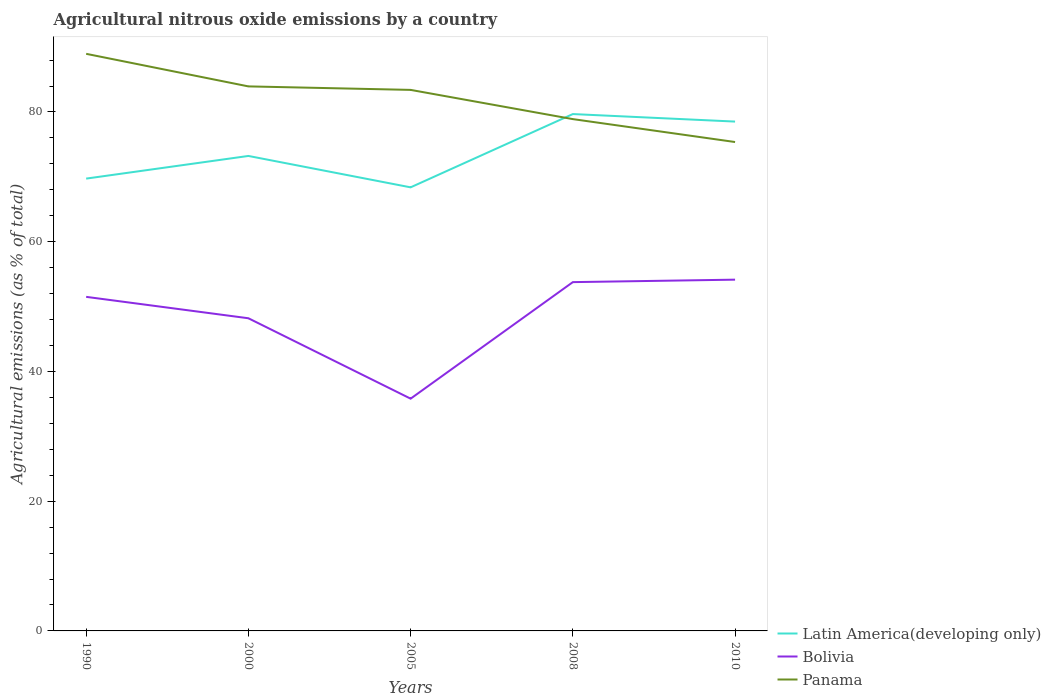Does the line corresponding to Bolivia intersect with the line corresponding to Panama?
Your answer should be compact. No. Is the number of lines equal to the number of legend labels?
Provide a short and direct response. Yes. Across all years, what is the maximum amount of agricultural nitrous oxide emitted in Panama?
Offer a very short reply. 75.37. What is the total amount of agricultural nitrous oxide emitted in Panama in the graph?
Provide a short and direct response. 4.5. What is the difference between the highest and the second highest amount of agricultural nitrous oxide emitted in Panama?
Your answer should be compact. 13.6. What is the difference between the highest and the lowest amount of agricultural nitrous oxide emitted in Bolivia?
Give a very brief answer. 3. Is the amount of agricultural nitrous oxide emitted in Panama strictly greater than the amount of agricultural nitrous oxide emitted in Latin America(developing only) over the years?
Ensure brevity in your answer.  No. What is the difference between two consecutive major ticks on the Y-axis?
Offer a terse response. 20. Are the values on the major ticks of Y-axis written in scientific E-notation?
Offer a very short reply. No. How are the legend labels stacked?
Provide a succinct answer. Vertical. What is the title of the graph?
Ensure brevity in your answer.  Agricultural nitrous oxide emissions by a country. What is the label or title of the Y-axis?
Give a very brief answer. Agricultural emissions (as % of total). What is the Agricultural emissions (as % of total) of Latin America(developing only) in 1990?
Provide a succinct answer. 69.73. What is the Agricultural emissions (as % of total) of Bolivia in 1990?
Provide a succinct answer. 51.5. What is the Agricultural emissions (as % of total) in Panama in 1990?
Your response must be concise. 88.97. What is the Agricultural emissions (as % of total) in Latin America(developing only) in 2000?
Offer a very short reply. 73.22. What is the Agricultural emissions (as % of total) in Bolivia in 2000?
Ensure brevity in your answer.  48.2. What is the Agricultural emissions (as % of total) of Panama in 2000?
Ensure brevity in your answer.  83.94. What is the Agricultural emissions (as % of total) in Latin America(developing only) in 2005?
Make the answer very short. 68.38. What is the Agricultural emissions (as % of total) of Bolivia in 2005?
Offer a terse response. 35.8. What is the Agricultural emissions (as % of total) in Panama in 2005?
Ensure brevity in your answer.  83.41. What is the Agricultural emissions (as % of total) of Latin America(developing only) in 2008?
Give a very brief answer. 79.68. What is the Agricultural emissions (as % of total) in Bolivia in 2008?
Your answer should be compact. 53.77. What is the Agricultural emissions (as % of total) in Panama in 2008?
Provide a succinct answer. 78.9. What is the Agricultural emissions (as % of total) of Latin America(developing only) in 2010?
Give a very brief answer. 78.52. What is the Agricultural emissions (as % of total) in Bolivia in 2010?
Offer a terse response. 54.15. What is the Agricultural emissions (as % of total) in Panama in 2010?
Your answer should be very brief. 75.37. Across all years, what is the maximum Agricultural emissions (as % of total) of Latin America(developing only)?
Provide a short and direct response. 79.68. Across all years, what is the maximum Agricultural emissions (as % of total) of Bolivia?
Your answer should be very brief. 54.15. Across all years, what is the maximum Agricultural emissions (as % of total) of Panama?
Give a very brief answer. 88.97. Across all years, what is the minimum Agricultural emissions (as % of total) of Latin America(developing only)?
Make the answer very short. 68.38. Across all years, what is the minimum Agricultural emissions (as % of total) in Bolivia?
Give a very brief answer. 35.8. Across all years, what is the minimum Agricultural emissions (as % of total) in Panama?
Your answer should be very brief. 75.37. What is the total Agricultural emissions (as % of total) in Latin America(developing only) in the graph?
Give a very brief answer. 369.54. What is the total Agricultural emissions (as % of total) of Bolivia in the graph?
Make the answer very short. 243.43. What is the total Agricultural emissions (as % of total) of Panama in the graph?
Your answer should be compact. 410.59. What is the difference between the Agricultural emissions (as % of total) in Latin America(developing only) in 1990 and that in 2000?
Provide a succinct answer. -3.49. What is the difference between the Agricultural emissions (as % of total) of Bolivia in 1990 and that in 2000?
Offer a terse response. 3.3. What is the difference between the Agricultural emissions (as % of total) in Panama in 1990 and that in 2000?
Give a very brief answer. 5.02. What is the difference between the Agricultural emissions (as % of total) in Latin America(developing only) in 1990 and that in 2005?
Offer a terse response. 1.35. What is the difference between the Agricultural emissions (as % of total) in Bolivia in 1990 and that in 2005?
Provide a short and direct response. 15.7. What is the difference between the Agricultural emissions (as % of total) in Panama in 1990 and that in 2005?
Your answer should be compact. 5.56. What is the difference between the Agricultural emissions (as % of total) in Latin America(developing only) in 1990 and that in 2008?
Your answer should be very brief. -9.95. What is the difference between the Agricultural emissions (as % of total) of Bolivia in 1990 and that in 2008?
Ensure brevity in your answer.  -2.27. What is the difference between the Agricultural emissions (as % of total) of Panama in 1990 and that in 2008?
Make the answer very short. 10.07. What is the difference between the Agricultural emissions (as % of total) of Latin America(developing only) in 1990 and that in 2010?
Provide a short and direct response. -8.79. What is the difference between the Agricultural emissions (as % of total) of Bolivia in 1990 and that in 2010?
Make the answer very short. -2.65. What is the difference between the Agricultural emissions (as % of total) in Panama in 1990 and that in 2010?
Make the answer very short. 13.6. What is the difference between the Agricultural emissions (as % of total) of Latin America(developing only) in 2000 and that in 2005?
Ensure brevity in your answer.  4.84. What is the difference between the Agricultural emissions (as % of total) in Bolivia in 2000 and that in 2005?
Your answer should be very brief. 12.4. What is the difference between the Agricultural emissions (as % of total) of Panama in 2000 and that in 2005?
Give a very brief answer. 0.54. What is the difference between the Agricultural emissions (as % of total) of Latin America(developing only) in 2000 and that in 2008?
Your answer should be very brief. -6.46. What is the difference between the Agricultural emissions (as % of total) of Bolivia in 2000 and that in 2008?
Make the answer very short. -5.57. What is the difference between the Agricultural emissions (as % of total) in Panama in 2000 and that in 2008?
Give a very brief answer. 5.04. What is the difference between the Agricultural emissions (as % of total) of Latin America(developing only) in 2000 and that in 2010?
Your answer should be very brief. -5.3. What is the difference between the Agricultural emissions (as % of total) in Bolivia in 2000 and that in 2010?
Offer a terse response. -5.95. What is the difference between the Agricultural emissions (as % of total) of Panama in 2000 and that in 2010?
Your answer should be very brief. 8.58. What is the difference between the Agricultural emissions (as % of total) in Latin America(developing only) in 2005 and that in 2008?
Offer a terse response. -11.3. What is the difference between the Agricultural emissions (as % of total) of Bolivia in 2005 and that in 2008?
Your answer should be compact. -17.97. What is the difference between the Agricultural emissions (as % of total) of Panama in 2005 and that in 2008?
Provide a short and direct response. 4.5. What is the difference between the Agricultural emissions (as % of total) in Latin America(developing only) in 2005 and that in 2010?
Offer a very short reply. -10.14. What is the difference between the Agricultural emissions (as % of total) of Bolivia in 2005 and that in 2010?
Keep it short and to the point. -18.35. What is the difference between the Agricultural emissions (as % of total) of Panama in 2005 and that in 2010?
Offer a terse response. 8.04. What is the difference between the Agricultural emissions (as % of total) of Latin America(developing only) in 2008 and that in 2010?
Offer a terse response. 1.16. What is the difference between the Agricultural emissions (as % of total) in Bolivia in 2008 and that in 2010?
Your answer should be compact. -0.38. What is the difference between the Agricultural emissions (as % of total) in Panama in 2008 and that in 2010?
Your response must be concise. 3.53. What is the difference between the Agricultural emissions (as % of total) in Latin America(developing only) in 1990 and the Agricultural emissions (as % of total) in Bolivia in 2000?
Make the answer very short. 21.53. What is the difference between the Agricultural emissions (as % of total) in Latin America(developing only) in 1990 and the Agricultural emissions (as % of total) in Panama in 2000?
Keep it short and to the point. -14.22. What is the difference between the Agricultural emissions (as % of total) in Bolivia in 1990 and the Agricultural emissions (as % of total) in Panama in 2000?
Provide a short and direct response. -32.44. What is the difference between the Agricultural emissions (as % of total) of Latin America(developing only) in 1990 and the Agricultural emissions (as % of total) of Bolivia in 2005?
Provide a short and direct response. 33.92. What is the difference between the Agricultural emissions (as % of total) in Latin America(developing only) in 1990 and the Agricultural emissions (as % of total) in Panama in 2005?
Make the answer very short. -13.68. What is the difference between the Agricultural emissions (as % of total) of Bolivia in 1990 and the Agricultural emissions (as % of total) of Panama in 2005?
Provide a short and direct response. -31.91. What is the difference between the Agricultural emissions (as % of total) of Latin America(developing only) in 1990 and the Agricultural emissions (as % of total) of Bolivia in 2008?
Offer a very short reply. 15.96. What is the difference between the Agricultural emissions (as % of total) in Latin America(developing only) in 1990 and the Agricultural emissions (as % of total) in Panama in 2008?
Offer a very short reply. -9.17. What is the difference between the Agricultural emissions (as % of total) in Bolivia in 1990 and the Agricultural emissions (as % of total) in Panama in 2008?
Ensure brevity in your answer.  -27.4. What is the difference between the Agricultural emissions (as % of total) of Latin America(developing only) in 1990 and the Agricultural emissions (as % of total) of Bolivia in 2010?
Ensure brevity in your answer.  15.58. What is the difference between the Agricultural emissions (as % of total) of Latin America(developing only) in 1990 and the Agricultural emissions (as % of total) of Panama in 2010?
Keep it short and to the point. -5.64. What is the difference between the Agricultural emissions (as % of total) of Bolivia in 1990 and the Agricultural emissions (as % of total) of Panama in 2010?
Your answer should be compact. -23.87. What is the difference between the Agricultural emissions (as % of total) of Latin America(developing only) in 2000 and the Agricultural emissions (as % of total) of Bolivia in 2005?
Offer a terse response. 37.42. What is the difference between the Agricultural emissions (as % of total) in Latin America(developing only) in 2000 and the Agricultural emissions (as % of total) in Panama in 2005?
Provide a short and direct response. -10.18. What is the difference between the Agricultural emissions (as % of total) in Bolivia in 2000 and the Agricultural emissions (as % of total) in Panama in 2005?
Offer a terse response. -35.21. What is the difference between the Agricultural emissions (as % of total) of Latin America(developing only) in 2000 and the Agricultural emissions (as % of total) of Bolivia in 2008?
Your answer should be very brief. 19.45. What is the difference between the Agricultural emissions (as % of total) of Latin America(developing only) in 2000 and the Agricultural emissions (as % of total) of Panama in 2008?
Make the answer very short. -5.68. What is the difference between the Agricultural emissions (as % of total) of Bolivia in 2000 and the Agricultural emissions (as % of total) of Panama in 2008?
Your response must be concise. -30.7. What is the difference between the Agricultural emissions (as % of total) in Latin America(developing only) in 2000 and the Agricultural emissions (as % of total) in Bolivia in 2010?
Offer a terse response. 19.07. What is the difference between the Agricultural emissions (as % of total) of Latin America(developing only) in 2000 and the Agricultural emissions (as % of total) of Panama in 2010?
Provide a succinct answer. -2.15. What is the difference between the Agricultural emissions (as % of total) in Bolivia in 2000 and the Agricultural emissions (as % of total) in Panama in 2010?
Your answer should be compact. -27.17. What is the difference between the Agricultural emissions (as % of total) of Latin America(developing only) in 2005 and the Agricultural emissions (as % of total) of Bolivia in 2008?
Ensure brevity in your answer.  14.61. What is the difference between the Agricultural emissions (as % of total) of Latin America(developing only) in 2005 and the Agricultural emissions (as % of total) of Panama in 2008?
Offer a terse response. -10.52. What is the difference between the Agricultural emissions (as % of total) in Bolivia in 2005 and the Agricultural emissions (as % of total) in Panama in 2008?
Offer a very short reply. -43.1. What is the difference between the Agricultural emissions (as % of total) of Latin America(developing only) in 2005 and the Agricultural emissions (as % of total) of Bolivia in 2010?
Keep it short and to the point. 14.23. What is the difference between the Agricultural emissions (as % of total) in Latin America(developing only) in 2005 and the Agricultural emissions (as % of total) in Panama in 2010?
Make the answer very short. -6.99. What is the difference between the Agricultural emissions (as % of total) in Bolivia in 2005 and the Agricultural emissions (as % of total) in Panama in 2010?
Provide a succinct answer. -39.56. What is the difference between the Agricultural emissions (as % of total) in Latin America(developing only) in 2008 and the Agricultural emissions (as % of total) in Bolivia in 2010?
Your answer should be very brief. 25.53. What is the difference between the Agricultural emissions (as % of total) of Latin America(developing only) in 2008 and the Agricultural emissions (as % of total) of Panama in 2010?
Provide a short and direct response. 4.31. What is the difference between the Agricultural emissions (as % of total) of Bolivia in 2008 and the Agricultural emissions (as % of total) of Panama in 2010?
Offer a terse response. -21.6. What is the average Agricultural emissions (as % of total) in Latin America(developing only) per year?
Provide a succinct answer. 73.91. What is the average Agricultural emissions (as % of total) of Bolivia per year?
Offer a terse response. 48.69. What is the average Agricultural emissions (as % of total) in Panama per year?
Offer a terse response. 82.12. In the year 1990, what is the difference between the Agricultural emissions (as % of total) in Latin America(developing only) and Agricultural emissions (as % of total) in Bolivia?
Make the answer very short. 18.23. In the year 1990, what is the difference between the Agricultural emissions (as % of total) in Latin America(developing only) and Agricultural emissions (as % of total) in Panama?
Your answer should be compact. -19.24. In the year 1990, what is the difference between the Agricultural emissions (as % of total) in Bolivia and Agricultural emissions (as % of total) in Panama?
Your answer should be compact. -37.47. In the year 2000, what is the difference between the Agricultural emissions (as % of total) of Latin America(developing only) and Agricultural emissions (as % of total) of Bolivia?
Your answer should be compact. 25.02. In the year 2000, what is the difference between the Agricultural emissions (as % of total) of Latin America(developing only) and Agricultural emissions (as % of total) of Panama?
Ensure brevity in your answer.  -10.72. In the year 2000, what is the difference between the Agricultural emissions (as % of total) in Bolivia and Agricultural emissions (as % of total) in Panama?
Your answer should be compact. -35.74. In the year 2005, what is the difference between the Agricultural emissions (as % of total) of Latin America(developing only) and Agricultural emissions (as % of total) of Bolivia?
Provide a short and direct response. 32.58. In the year 2005, what is the difference between the Agricultural emissions (as % of total) in Latin America(developing only) and Agricultural emissions (as % of total) in Panama?
Your answer should be very brief. -15.02. In the year 2005, what is the difference between the Agricultural emissions (as % of total) in Bolivia and Agricultural emissions (as % of total) in Panama?
Provide a succinct answer. -47.6. In the year 2008, what is the difference between the Agricultural emissions (as % of total) of Latin America(developing only) and Agricultural emissions (as % of total) of Bolivia?
Offer a terse response. 25.91. In the year 2008, what is the difference between the Agricultural emissions (as % of total) of Latin America(developing only) and Agricultural emissions (as % of total) of Panama?
Your answer should be compact. 0.78. In the year 2008, what is the difference between the Agricultural emissions (as % of total) in Bolivia and Agricultural emissions (as % of total) in Panama?
Your answer should be very brief. -25.13. In the year 2010, what is the difference between the Agricultural emissions (as % of total) of Latin America(developing only) and Agricultural emissions (as % of total) of Bolivia?
Your answer should be compact. 24.37. In the year 2010, what is the difference between the Agricultural emissions (as % of total) of Latin America(developing only) and Agricultural emissions (as % of total) of Panama?
Offer a terse response. 3.15. In the year 2010, what is the difference between the Agricultural emissions (as % of total) of Bolivia and Agricultural emissions (as % of total) of Panama?
Offer a very short reply. -21.22. What is the ratio of the Agricultural emissions (as % of total) of Latin America(developing only) in 1990 to that in 2000?
Offer a terse response. 0.95. What is the ratio of the Agricultural emissions (as % of total) of Bolivia in 1990 to that in 2000?
Ensure brevity in your answer.  1.07. What is the ratio of the Agricultural emissions (as % of total) in Panama in 1990 to that in 2000?
Make the answer very short. 1.06. What is the ratio of the Agricultural emissions (as % of total) in Latin America(developing only) in 1990 to that in 2005?
Offer a very short reply. 1.02. What is the ratio of the Agricultural emissions (as % of total) in Bolivia in 1990 to that in 2005?
Keep it short and to the point. 1.44. What is the ratio of the Agricultural emissions (as % of total) of Panama in 1990 to that in 2005?
Ensure brevity in your answer.  1.07. What is the ratio of the Agricultural emissions (as % of total) of Latin America(developing only) in 1990 to that in 2008?
Your answer should be very brief. 0.88. What is the ratio of the Agricultural emissions (as % of total) in Bolivia in 1990 to that in 2008?
Offer a terse response. 0.96. What is the ratio of the Agricultural emissions (as % of total) of Panama in 1990 to that in 2008?
Your answer should be very brief. 1.13. What is the ratio of the Agricultural emissions (as % of total) in Latin America(developing only) in 1990 to that in 2010?
Keep it short and to the point. 0.89. What is the ratio of the Agricultural emissions (as % of total) of Bolivia in 1990 to that in 2010?
Keep it short and to the point. 0.95. What is the ratio of the Agricultural emissions (as % of total) in Panama in 1990 to that in 2010?
Provide a succinct answer. 1.18. What is the ratio of the Agricultural emissions (as % of total) in Latin America(developing only) in 2000 to that in 2005?
Ensure brevity in your answer.  1.07. What is the ratio of the Agricultural emissions (as % of total) of Bolivia in 2000 to that in 2005?
Provide a short and direct response. 1.35. What is the ratio of the Agricultural emissions (as % of total) of Latin America(developing only) in 2000 to that in 2008?
Provide a short and direct response. 0.92. What is the ratio of the Agricultural emissions (as % of total) of Bolivia in 2000 to that in 2008?
Make the answer very short. 0.9. What is the ratio of the Agricultural emissions (as % of total) in Panama in 2000 to that in 2008?
Ensure brevity in your answer.  1.06. What is the ratio of the Agricultural emissions (as % of total) in Latin America(developing only) in 2000 to that in 2010?
Make the answer very short. 0.93. What is the ratio of the Agricultural emissions (as % of total) of Bolivia in 2000 to that in 2010?
Give a very brief answer. 0.89. What is the ratio of the Agricultural emissions (as % of total) in Panama in 2000 to that in 2010?
Provide a succinct answer. 1.11. What is the ratio of the Agricultural emissions (as % of total) of Latin America(developing only) in 2005 to that in 2008?
Provide a succinct answer. 0.86. What is the ratio of the Agricultural emissions (as % of total) in Bolivia in 2005 to that in 2008?
Make the answer very short. 0.67. What is the ratio of the Agricultural emissions (as % of total) of Panama in 2005 to that in 2008?
Ensure brevity in your answer.  1.06. What is the ratio of the Agricultural emissions (as % of total) in Latin America(developing only) in 2005 to that in 2010?
Your answer should be very brief. 0.87. What is the ratio of the Agricultural emissions (as % of total) in Bolivia in 2005 to that in 2010?
Make the answer very short. 0.66. What is the ratio of the Agricultural emissions (as % of total) in Panama in 2005 to that in 2010?
Provide a succinct answer. 1.11. What is the ratio of the Agricultural emissions (as % of total) in Latin America(developing only) in 2008 to that in 2010?
Ensure brevity in your answer.  1.01. What is the ratio of the Agricultural emissions (as % of total) of Panama in 2008 to that in 2010?
Provide a short and direct response. 1.05. What is the difference between the highest and the second highest Agricultural emissions (as % of total) in Latin America(developing only)?
Provide a short and direct response. 1.16. What is the difference between the highest and the second highest Agricultural emissions (as % of total) of Bolivia?
Provide a succinct answer. 0.38. What is the difference between the highest and the second highest Agricultural emissions (as % of total) in Panama?
Your answer should be compact. 5.02. What is the difference between the highest and the lowest Agricultural emissions (as % of total) of Latin America(developing only)?
Make the answer very short. 11.3. What is the difference between the highest and the lowest Agricultural emissions (as % of total) in Bolivia?
Your answer should be very brief. 18.35. What is the difference between the highest and the lowest Agricultural emissions (as % of total) in Panama?
Your answer should be very brief. 13.6. 